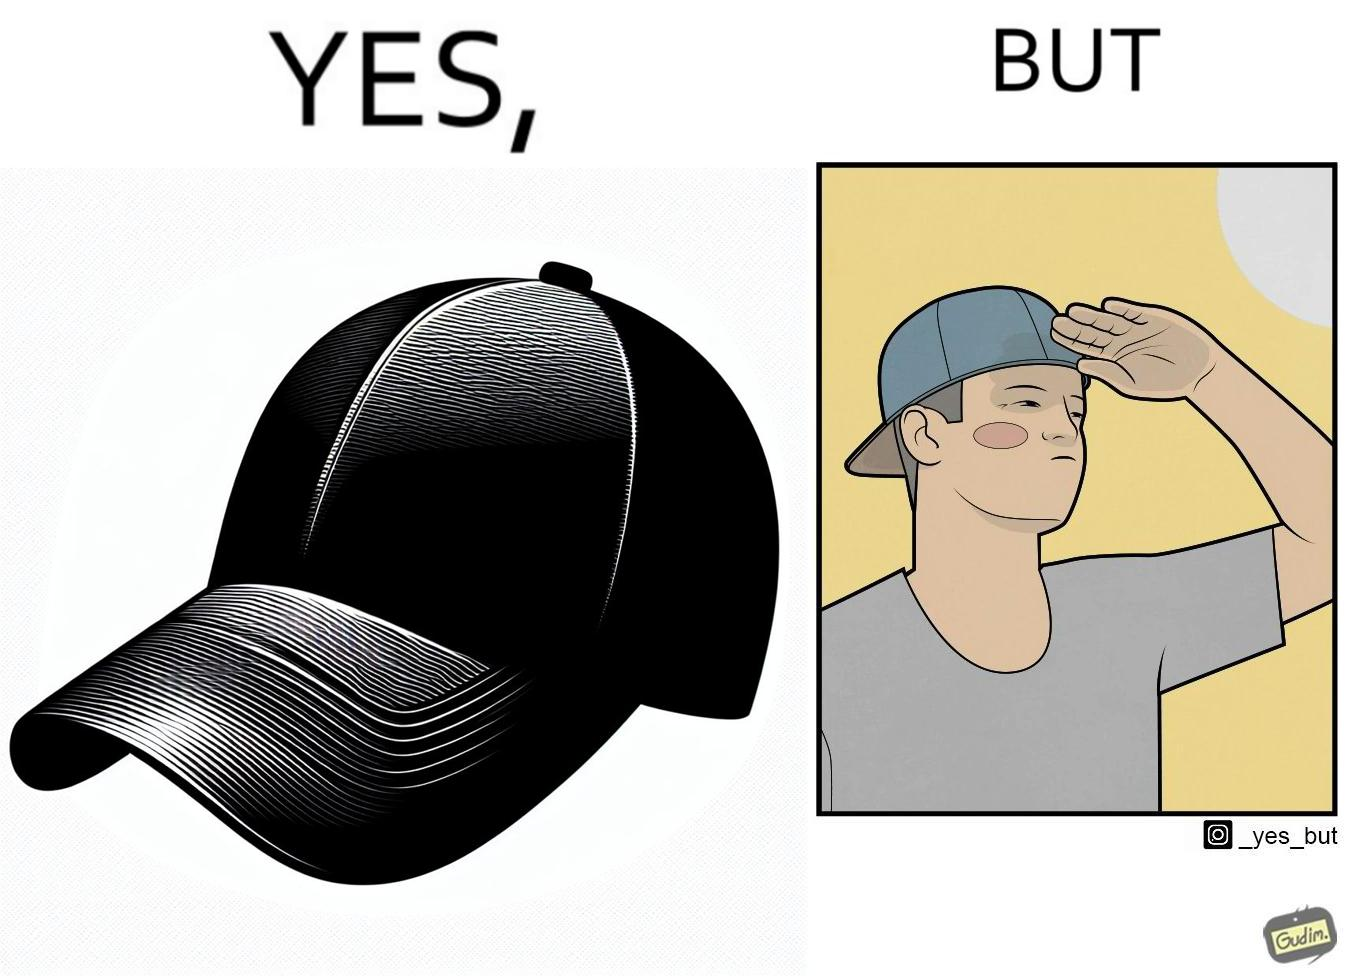Is this image satirical or non-satirical? Yes, this image is satirical. 